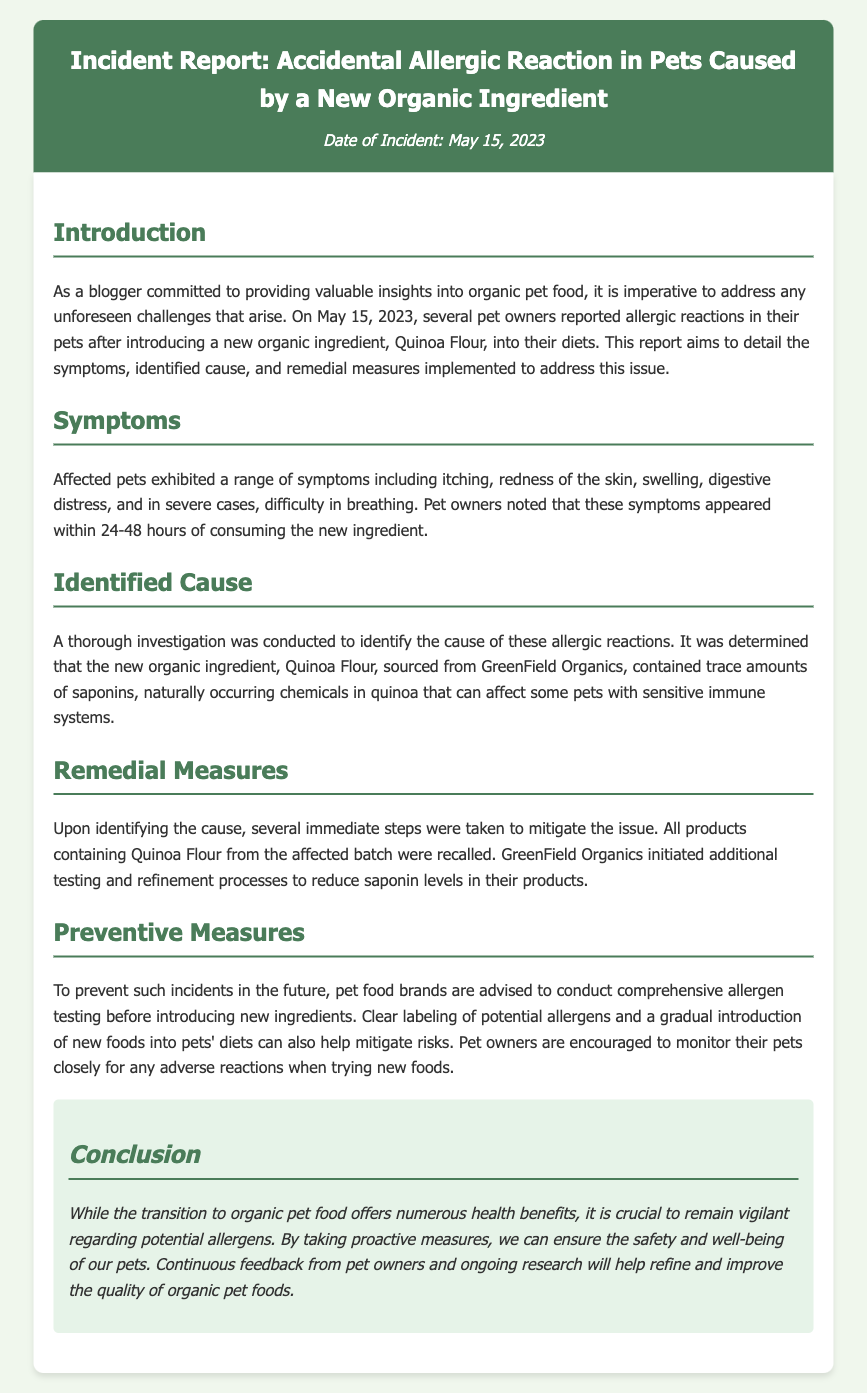What was the new organic ingredient that caused the allergic reaction? The new organic ingredient that caused the allergic reaction was Quinoa Flour.
Answer: Quinoa Flour When did the incident occur? The date of the incident is provided in the document.
Answer: May 15, 2023 What symptoms did affected pets exhibit? The document mentions several specific symptoms exhibited by affected pets.
Answer: Itching, redness, swelling, digestive distress, difficulty in breathing What company sourced the Quinoa Flour? The document states the name of the company that sourced the Quinoa Flour.
Answer: GreenField Organics What immediate action was taken after identifying the cause? The document describes an immediate corrective action taken after the investigation.
Answer: Products containing Quinoa Flour were recalled What is advised to prevent future incidents? The document lists a key preventive measure for future incidents with new ingredients.
Answer: Comprehensive allergen testing What should pet owners do when trying new foods? The document suggests an important action for pet owners.
Answer: Monitor their pets closely What is the primary purpose of the incident report? The introduction section outlines the main goal of the incident report.
Answer: To detail the symptoms, identified cause, and remedial measures implemented 